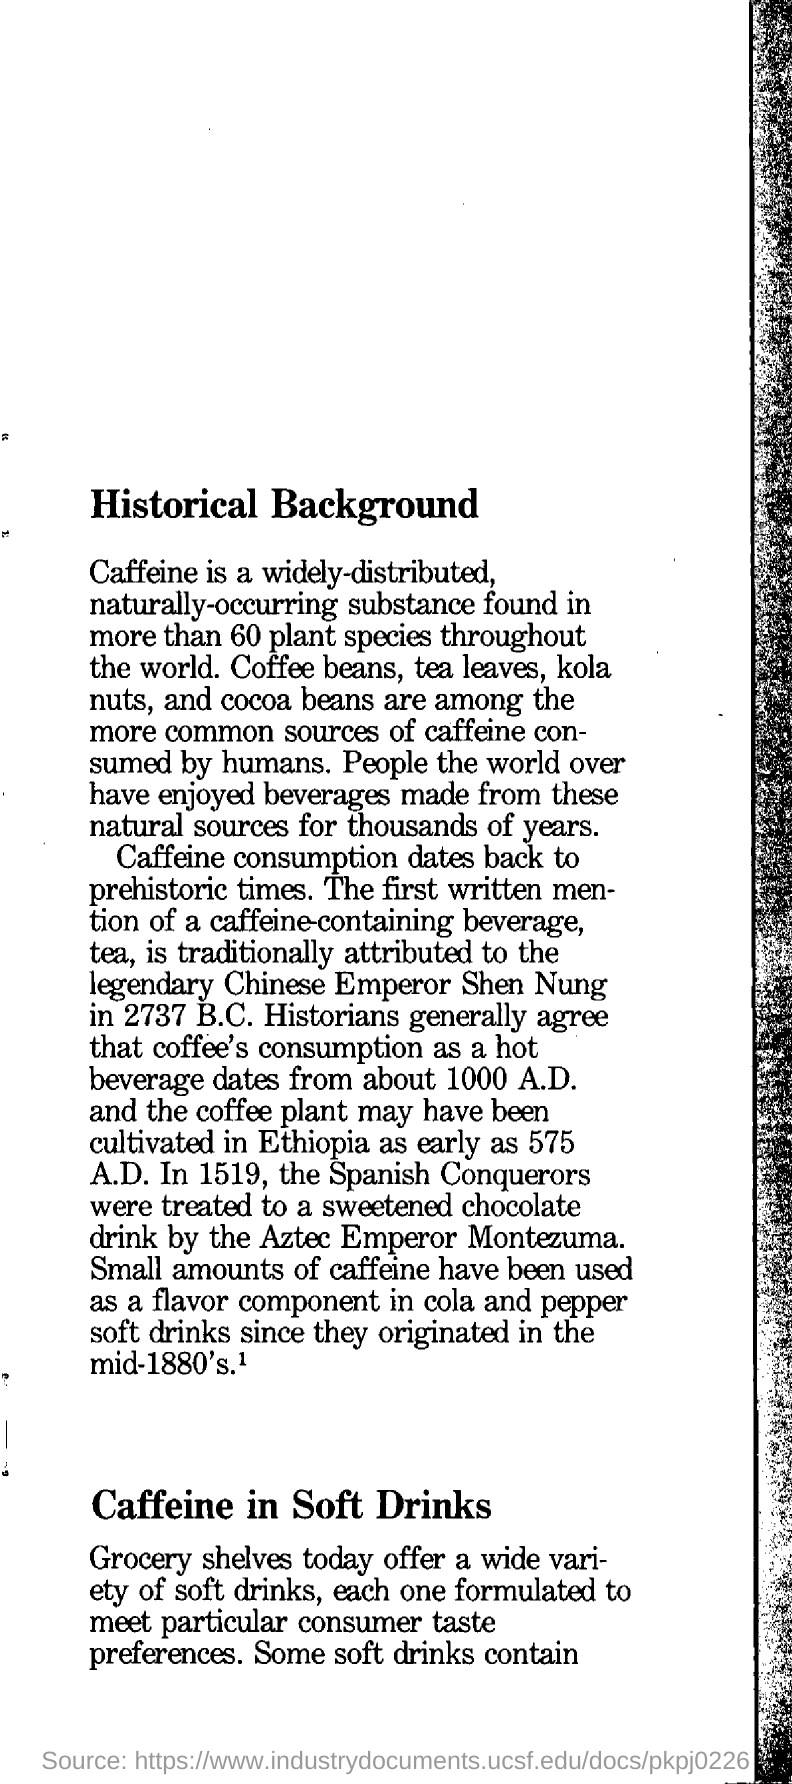What is the title of the page?
Your answer should be very brief. Historical background. What are the common sources of caffeine consumed by humans?
Provide a short and direct response. Coffee beans, tea leaves, kola nuts and cocoa beans. What is widely distributed naturally occuring substance found in more than 60 plant species throughout he world?
Offer a terse response. Caffeine. Who is traditionally  attributed to legendary for the first written mention of a coffee containing beverage tea?
Offer a terse response. Chinese emperor shen nung. Who were treated to a sweetened chocolate drink by aztec emporer montezuma?
Ensure brevity in your answer.  The spanish conquerors. 